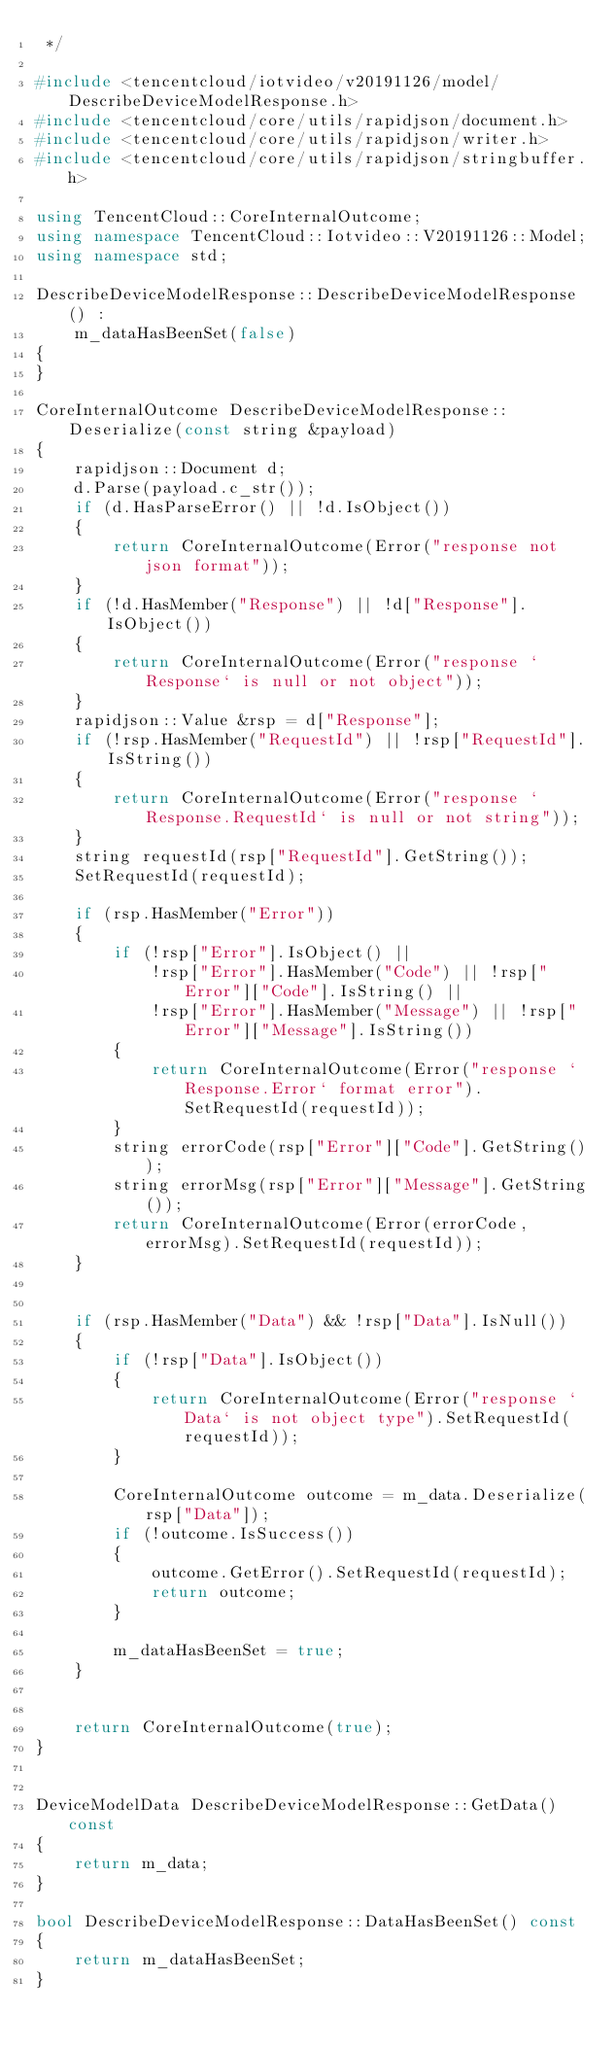<code> <loc_0><loc_0><loc_500><loc_500><_C++_> */

#include <tencentcloud/iotvideo/v20191126/model/DescribeDeviceModelResponse.h>
#include <tencentcloud/core/utils/rapidjson/document.h>
#include <tencentcloud/core/utils/rapidjson/writer.h>
#include <tencentcloud/core/utils/rapidjson/stringbuffer.h>

using TencentCloud::CoreInternalOutcome;
using namespace TencentCloud::Iotvideo::V20191126::Model;
using namespace std;

DescribeDeviceModelResponse::DescribeDeviceModelResponse() :
    m_dataHasBeenSet(false)
{
}

CoreInternalOutcome DescribeDeviceModelResponse::Deserialize(const string &payload)
{
    rapidjson::Document d;
    d.Parse(payload.c_str());
    if (d.HasParseError() || !d.IsObject())
    {
        return CoreInternalOutcome(Error("response not json format"));
    }
    if (!d.HasMember("Response") || !d["Response"].IsObject())
    {
        return CoreInternalOutcome(Error("response `Response` is null or not object"));
    }
    rapidjson::Value &rsp = d["Response"];
    if (!rsp.HasMember("RequestId") || !rsp["RequestId"].IsString())
    {
        return CoreInternalOutcome(Error("response `Response.RequestId` is null or not string"));
    }
    string requestId(rsp["RequestId"].GetString());
    SetRequestId(requestId);

    if (rsp.HasMember("Error"))
    {
        if (!rsp["Error"].IsObject() ||
            !rsp["Error"].HasMember("Code") || !rsp["Error"]["Code"].IsString() ||
            !rsp["Error"].HasMember("Message") || !rsp["Error"]["Message"].IsString())
        {
            return CoreInternalOutcome(Error("response `Response.Error` format error").SetRequestId(requestId));
        }
        string errorCode(rsp["Error"]["Code"].GetString());
        string errorMsg(rsp["Error"]["Message"].GetString());
        return CoreInternalOutcome(Error(errorCode, errorMsg).SetRequestId(requestId));
    }


    if (rsp.HasMember("Data") && !rsp["Data"].IsNull())
    {
        if (!rsp["Data"].IsObject())
        {
            return CoreInternalOutcome(Error("response `Data` is not object type").SetRequestId(requestId));
        }

        CoreInternalOutcome outcome = m_data.Deserialize(rsp["Data"]);
        if (!outcome.IsSuccess())
        {
            outcome.GetError().SetRequestId(requestId);
            return outcome;
        }

        m_dataHasBeenSet = true;
    }


    return CoreInternalOutcome(true);
}


DeviceModelData DescribeDeviceModelResponse::GetData() const
{
    return m_data;
}

bool DescribeDeviceModelResponse::DataHasBeenSet() const
{
    return m_dataHasBeenSet;
}


</code> 